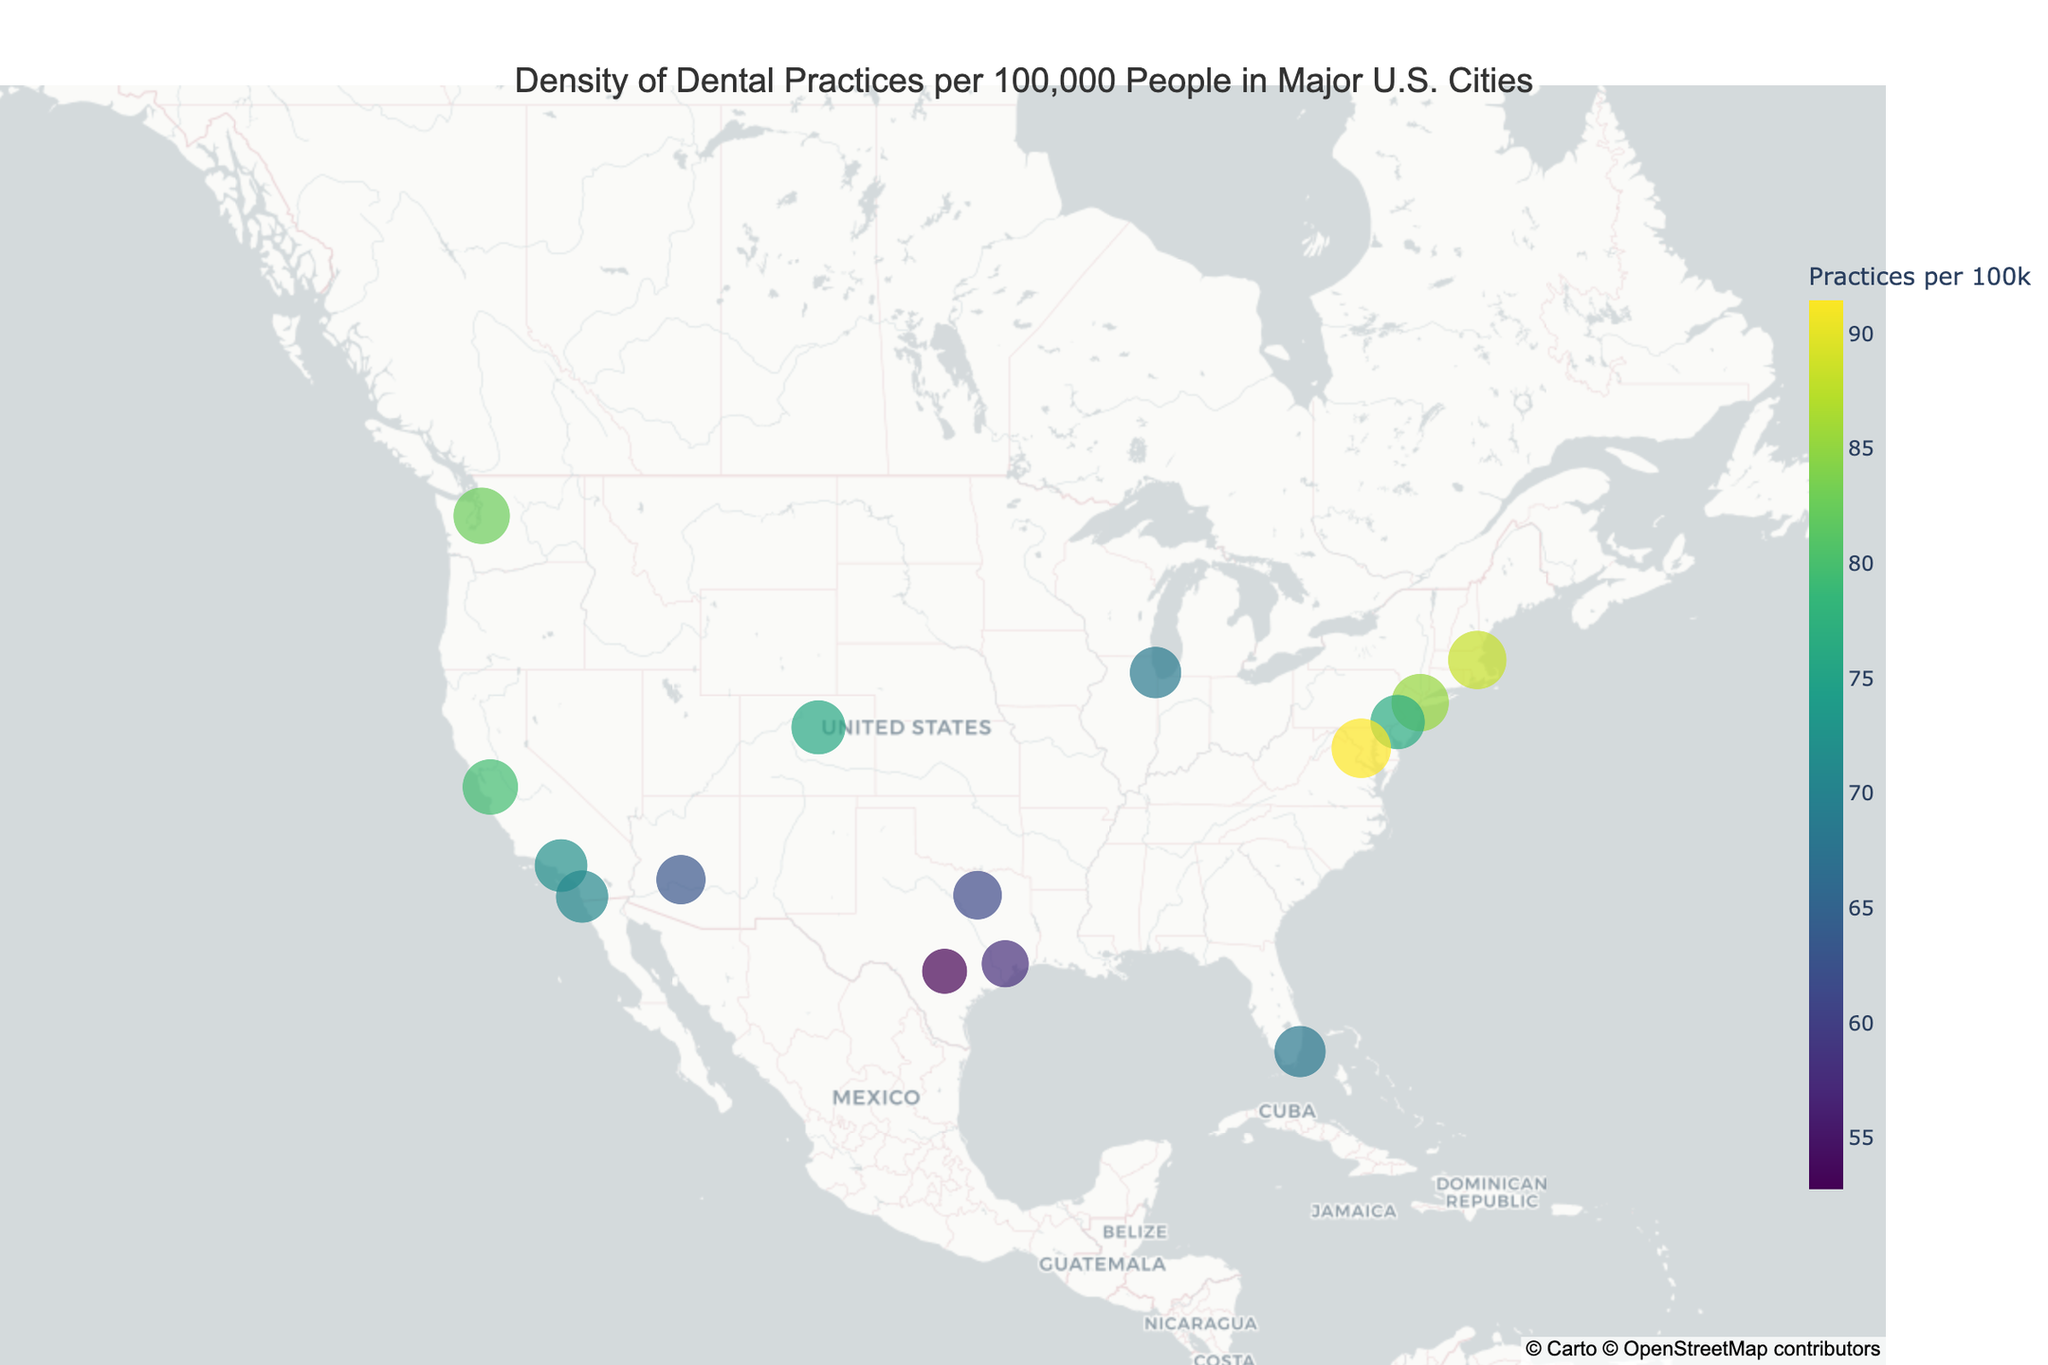What's the title of the figure? The title of the figure is usually displayed at the top center.
Answer: Density of Dental Practices per 100,000 People in Major U.S. Cities Which city has the highest density of dental practices per 100,000 people? Locate the city marker with the highest number on the legend.
Answer: Washington, DC How many cities are represented in the figure? Count each unique city marker on the map.
Answer: 15 What is the density of dental practices per 100,000 people in Seattle, WA? Hover over the Seattle marker to view the specific details.
Answer: 82.7 How does the density of dental practices in Boston, MA compare to that in New York City, NY? Check the values for both cities and compare. Boston, MA has a density of 88.2, and New York City, NY has 85.3.
Answer: Boston has a higher density than New York City What is the average density of dental practices per 100,000 people for cities in Texas (Houston, San Antonio, Dallas)? Find the values for Houston (57.9), San Antonio (52.8), and Dallas (61.4). Add these values and divide by 3 to get the average. (57.9 + 52.8 + 61.4) / 3 = 57.37
Answer: 57.37 Which state has the most cities represented in the figure? Identify the states of all cities and count occurrences for each state. California has Los Angeles, San Diego, and San Jose.
Answer: California What is the range of dental practices densities in the figure? Find the highest (Washington, DC at 91.5) and lowest (San Antonio, TX at 52.8) densities and subtract the lowest from the highest. 91.5 - 52.8 = 38.7
Answer: 38.7 Which city has the closest density of dental practices per 100,000 people to the average density of all the cities? First, calculate the average density for all cities. Sum the densities and divide by the number of cities. (85.3 + 72.1 + 68.7 + 57.9 + 63.2 + 76.5 + 52.8 + 70.9 + 61.4 + 79.6 + 88.2 + 82.7 + 75.8 + 91.5 + 68.3) / 15 ≈ 72.5. Compare this to all cities' densities.
Answer: Los Angeles, CA (72.1) Which city in California has the highest density of dental practices per 100,000 people? Find the values for all California cities: Los Angeles (72.1), San Diego (70.9), and San Jose (79.6).
Answer: San Jose, CA 